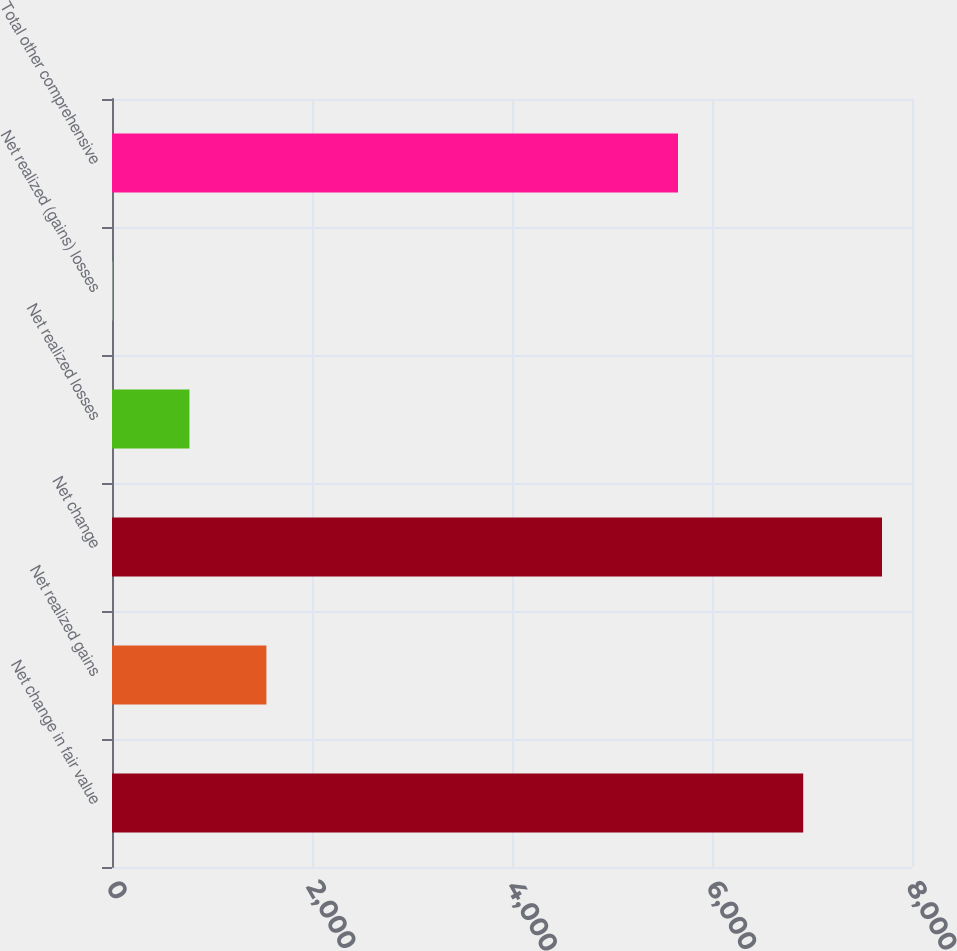Convert chart to OTSL. <chart><loc_0><loc_0><loc_500><loc_500><bar_chart><fcel>Net change in fair value<fcel>Net realized gains<fcel>Net change<fcel>Net realized losses<fcel>Net realized (gains) losses<fcel>Total other comprehensive<nl><fcel>6912<fcel>1544<fcel>7700<fcel>774.5<fcel>5<fcel>5660<nl></chart> 